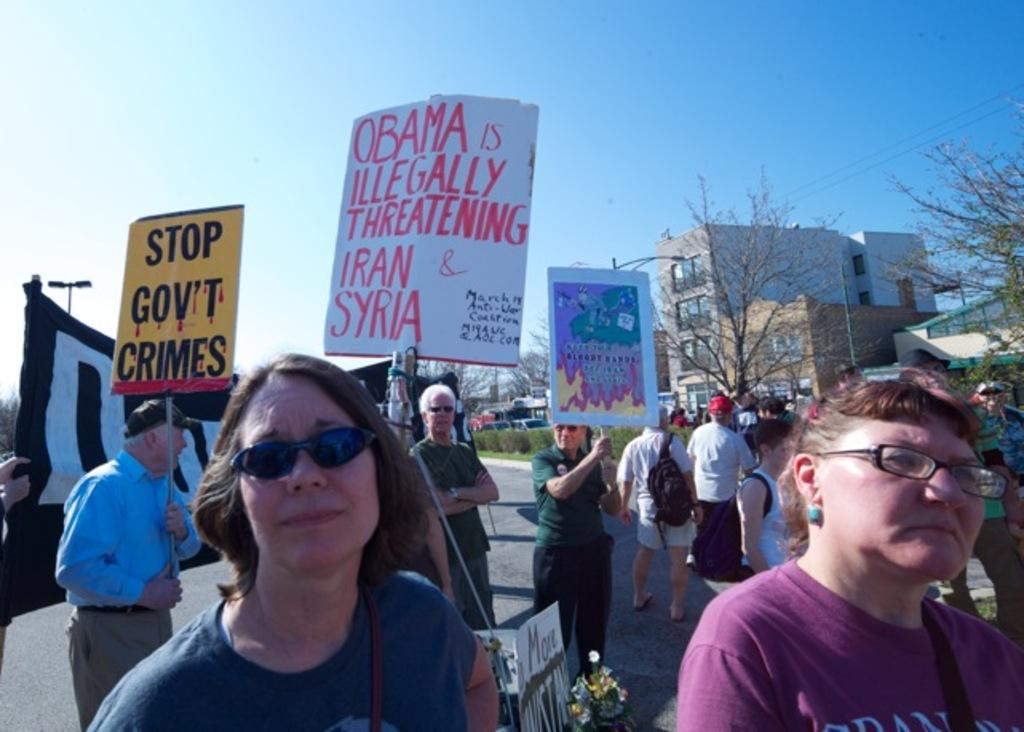How many people are in the group visible in the image? There is a group of people in the image, but the exact number cannot be determined from the provided facts. What can be seen hanging or displayed in the image? There are banners in the image. What type of natural elements are present in the image? There are trees and plants in the image. What type of man-made structures can be seen in the image? There are vehicles, buildings, and banners in the image. What is visible at the top of the image? The sky is visible at the top of the image. What type of tin is being distributed by the people in the image? There is no tin present in the image, nor is there any indication of distribution or people handing out items. 